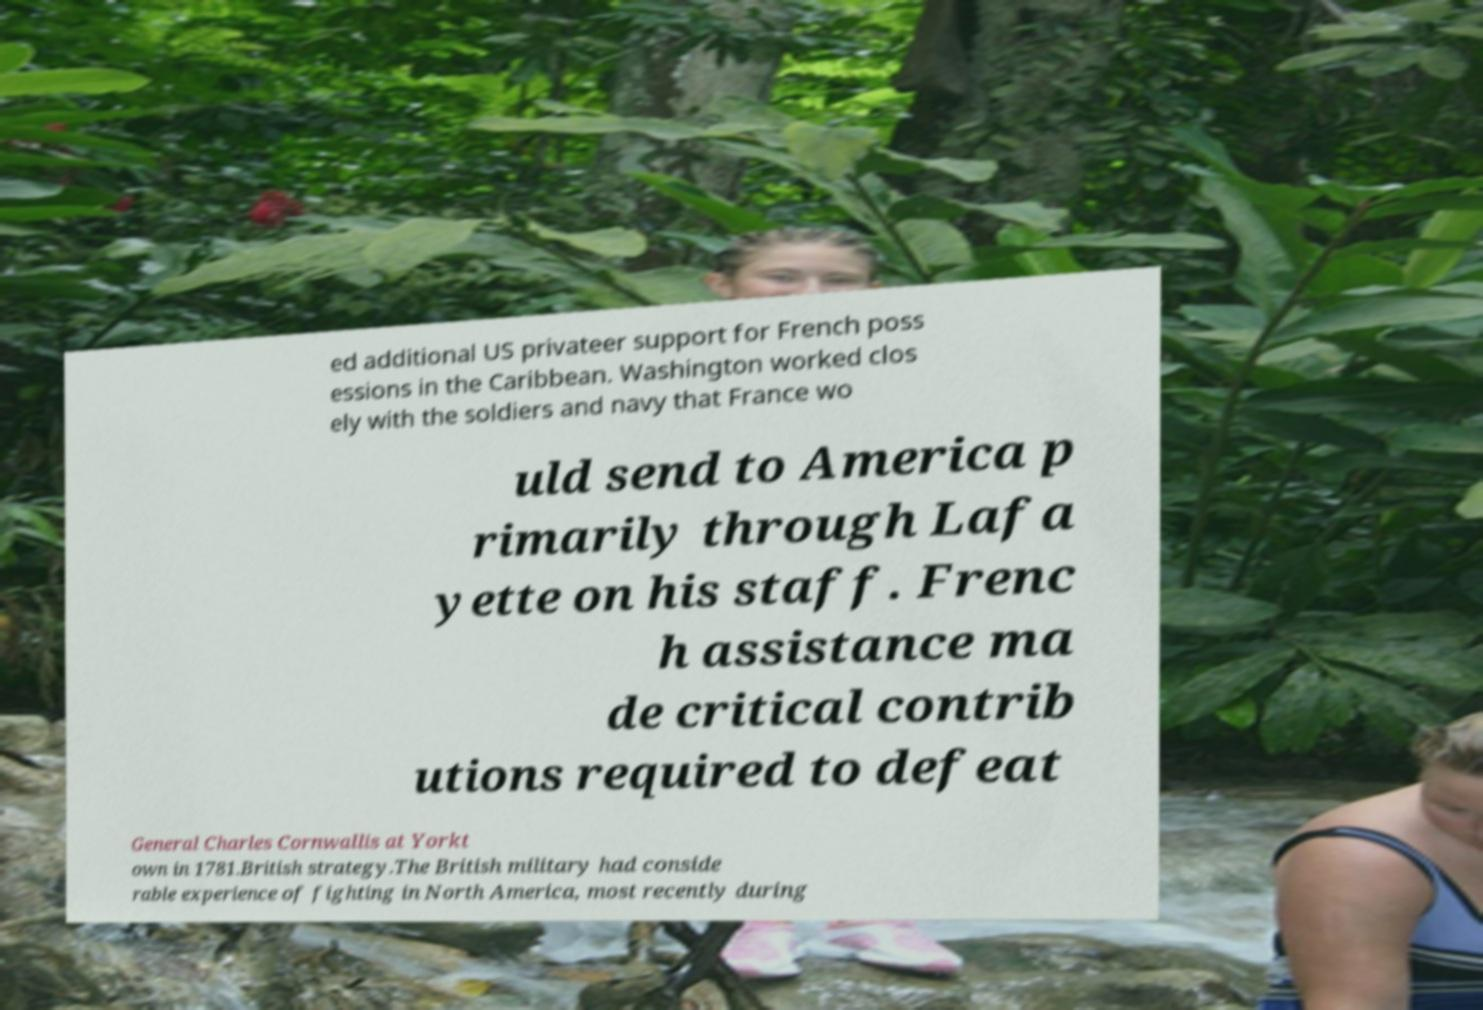There's text embedded in this image that I need extracted. Can you transcribe it verbatim? ed additional US privateer support for French poss essions in the Caribbean. Washington worked clos ely with the soldiers and navy that France wo uld send to America p rimarily through Lafa yette on his staff. Frenc h assistance ma de critical contrib utions required to defeat General Charles Cornwallis at Yorkt own in 1781.British strategy.The British military had conside rable experience of fighting in North America, most recently during 